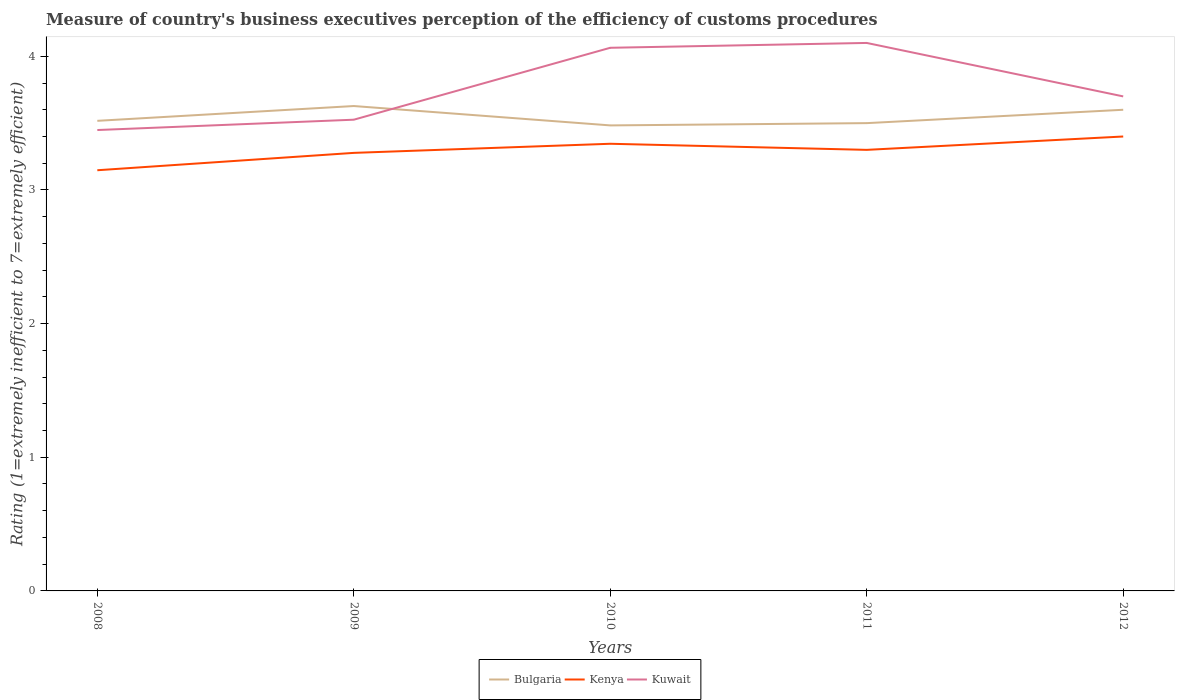How many different coloured lines are there?
Your answer should be compact. 3. Is the number of lines equal to the number of legend labels?
Give a very brief answer. Yes. Across all years, what is the maximum rating of the efficiency of customs procedure in Bulgaria?
Make the answer very short. 3.48. In which year was the rating of the efficiency of customs procedure in Bulgaria maximum?
Offer a terse response. 2010. What is the total rating of the efficiency of customs procedure in Kuwait in the graph?
Make the answer very short. -0.62. What is the difference between the highest and the second highest rating of the efficiency of customs procedure in Kuwait?
Your answer should be very brief. 0.65. How many years are there in the graph?
Your response must be concise. 5. What is the difference between two consecutive major ticks on the Y-axis?
Provide a succinct answer. 1. Does the graph contain any zero values?
Give a very brief answer. No. Does the graph contain grids?
Your answer should be very brief. No. How many legend labels are there?
Ensure brevity in your answer.  3. What is the title of the graph?
Keep it short and to the point. Measure of country's business executives perception of the efficiency of customs procedures. Does "Bhutan" appear as one of the legend labels in the graph?
Your answer should be compact. No. What is the label or title of the X-axis?
Your answer should be very brief. Years. What is the label or title of the Y-axis?
Your answer should be very brief. Rating (1=extremely inefficient to 7=extremely efficient). What is the Rating (1=extremely inefficient to 7=extremely efficient) in Bulgaria in 2008?
Provide a succinct answer. 3.52. What is the Rating (1=extremely inefficient to 7=extremely efficient) in Kenya in 2008?
Your response must be concise. 3.15. What is the Rating (1=extremely inefficient to 7=extremely efficient) in Kuwait in 2008?
Your answer should be very brief. 3.45. What is the Rating (1=extremely inefficient to 7=extremely efficient) in Bulgaria in 2009?
Your answer should be compact. 3.63. What is the Rating (1=extremely inefficient to 7=extremely efficient) of Kenya in 2009?
Make the answer very short. 3.28. What is the Rating (1=extremely inefficient to 7=extremely efficient) of Kuwait in 2009?
Provide a succinct answer. 3.53. What is the Rating (1=extremely inefficient to 7=extremely efficient) of Bulgaria in 2010?
Offer a terse response. 3.48. What is the Rating (1=extremely inefficient to 7=extremely efficient) in Kenya in 2010?
Offer a very short reply. 3.35. What is the Rating (1=extremely inefficient to 7=extremely efficient) of Kuwait in 2010?
Make the answer very short. 4.06. What is the Rating (1=extremely inefficient to 7=extremely efficient) in Bulgaria in 2012?
Offer a terse response. 3.6. Across all years, what is the maximum Rating (1=extremely inefficient to 7=extremely efficient) in Bulgaria?
Your answer should be compact. 3.63. Across all years, what is the maximum Rating (1=extremely inefficient to 7=extremely efficient) of Kenya?
Ensure brevity in your answer.  3.4. Across all years, what is the maximum Rating (1=extremely inefficient to 7=extremely efficient) in Kuwait?
Offer a terse response. 4.1. Across all years, what is the minimum Rating (1=extremely inefficient to 7=extremely efficient) of Bulgaria?
Offer a very short reply. 3.48. Across all years, what is the minimum Rating (1=extremely inefficient to 7=extremely efficient) of Kenya?
Your response must be concise. 3.15. Across all years, what is the minimum Rating (1=extremely inefficient to 7=extremely efficient) in Kuwait?
Provide a succinct answer. 3.45. What is the total Rating (1=extremely inefficient to 7=extremely efficient) of Bulgaria in the graph?
Offer a terse response. 17.73. What is the total Rating (1=extremely inefficient to 7=extremely efficient) of Kenya in the graph?
Give a very brief answer. 16.47. What is the total Rating (1=extremely inefficient to 7=extremely efficient) in Kuwait in the graph?
Provide a short and direct response. 18.84. What is the difference between the Rating (1=extremely inefficient to 7=extremely efficient) in Bulgaria in 2008 and that in 2009?
Your answer should be compact. -0.11. What is the difference between the Rating (1=extremely inefficient to 7=extremely efficient) in Kenya in 2008 and that in 2009?
Offer a very short reply. -0.13. What is the difference between the Rating (1=extremely inefficient to 7=extremely efficient) of Kuwait in 2008 and that in 2009?
Offer a very short reply. -0.08. What is the difference between the Rating (1=extremely inefficient to 7=extremely efficient) of Bulgaria in 2008 and that in 2010?
Your response must be concise. 0.03. What is the difference between the Rating (1=extremely inefficient to 7=extremely efficient) of Kenya in 2008 and that in 2010?
Keep it short and to the point. -0.2. What is the difference between the Rating (1=extremely inefficient to 7=extremely efficient) of Kuwait in 2008 and that in 2010?
Offer a terse response. -0.62. What is the difference between the Rating (1=extremely inefficient to 7=extremely efficient) of Bulgaria in 2008 and that in 2011?
Ensure brevity in your answer.  0.02. What is the difference between the Rating (1=extremely inefficient to 7=extremely efficient) in Kenya in 2008 and that in 2011?
Your answer should be compact. -0.15. What is the difference between the Rating (1=extremely inefficient to 7=extremely efficient) of Kuwait in 2008 and that in 2011?
Make the answer very short. -0.65. What is the difference between the Rating (1=extremely inefficient to 7=extremely efficient) of Bulgaria in 2008 and that in 2012?
Your answer should be compact. -0.08. What is the difference between the Rating (1=extremely inefficient to 7=extremely efficient) of Kenya in 2008 and that in 2012?
Make the answer very short. -0.25. What is the difference between the Rating (1=extremely inefficient to 7=extremely efficient) of Kuwait in 2008 and that in 2012?
Give a very brief answer. -0.25. What is the difference between the Rating (1=extremely inefficient to 7=extremely efficient) in Bulgaria in 2009 and that in 2010?
Give a very brief answer. 0.14. What is the difference between the Rating (1=extremely inefficient to 7=extremely efficient) of Kenya in 2009 and that in 2010?
Make the answer very short. -0.07. What is the difference between the Rating (1=extremely inefficient to 7=extremely efficient) in Kuwait in 2009 and that in 2010?
Make the answer very short. -0.54. What is the difference between the Rating (1=extremely inefficient to 7=extremely efficient) in Bulgaria in 2009 and that in 2011?
Offer a very short reply. 0.13. What is the difference between the Rating (1=extremely inefficient to 7=extremely efficient) in Kenya in 2009 and that in 2011?
Your response must be concise. -0.02. What is the difference between the Rating (1=extremely inefficient to 7=extremely efficient) in Kuwait in 2009 and that in 2011?
Provide a succinct answer. -0.57. What is the difference between the Rating (1=extremely inefficient to 7=extremely efficient) in Bulgaria in 2009 and that in 2012?
Provide a short and direct response. 0.03. What is the difference between the Rating (1=extremely inefficient to 7=extremely efficient) of Kenya in 2009 and that in 2012?
Keep it short and to the point. -0.12. What is the difference between the Rating (1=extremely inefficient to 7=extremely efficient) of Kuwait in 2009 and that in 2012?
Give a very brief answer. -0.17. What is the difference between the Rating (1=extremely inefficient to 7=extremely efficient) of Bulgaria in 2010 and that in 2011?
Your answer should be compact. -0.02. What is the difference between the Rating (1=extremely inefficient to 7=extremely efficient) in Kenya in 2010 and that in 2011?
Make the answer very short. 0.05. What is the difference between the Rating (1=extremely inefficient to 7=extremely efficient) of Kuwait in 2010 and that in 2011?
Provide a succinct answer. -0.04. What is the difference between the Rating (1=extremely inefficient to 7=extremely efficient) of Bulgaria in 2010 and that in 2012?
Your response must be concise. -0.12. What is the difference between the Rating (1=extremely inefficient to 7=extremely efficient) of Kenya in 2010 and that in 2012?
Provide a succinct answer. -0.05. What is the difference between the Rating (1=extremely inefficient to 7=extremely efficient) of Kuwait in 2010 and that in 2012?
Ensure brevity in your answer.  0.36. What is the difference between the Rating (1=extremely inefficient to 7=extremely efficient) in Kenya in 2011 and that in 2012?
Your answer should be very brief. -0.1. What is the difference between the Rating (1=extremely inefficient to 7=extremely efficient) of Kuwait in 2011 and that in 2012?
Provide a succinct answer. 0.4. What is the difference between the Rating (1=extremely inefficient to 7=extremely efficient) of Bulgaria in 2008 and the Rating (1=extremely inefficient to 7=extremely efficient) of Kenya in 2009?
Your answer should be compact. 0.24. What is the difference between the Rating (1=extremely inefficient to 7=extremely efficient) of Bulgaria in 2008 and the Rating (1=extremely inefficient to 7=extremely efficient) of Kuwait in 2009?
Your answer should be compact. -0.01. What is the difference between the Rating (1=extremely inefficient to 7=extremely efficient) in Kenya in 2008 and the Rating (1=extremely inefficient to 7=extremely efficient) in Kuwait in 2009?
Offer a terse response. -0.38. What is the difference between the Rating (1=extremely inefficient to 7=extremely efficient) in Bulgaria in 2008 and the Rating (1=extremely inefficient to 7=extremely efficient) in Kenya in 2010?
Your answer should be compact. 0.17. What is the difference between the Rating (1=extremely inefficient to 7=extremely efficient) in Bulgaria in 2008 and the Rating (1=extremely inefficient to 7=extremely efficient) in Kuwait in 2010?
Provide a short and direct response. -0.55. What is the difference between the Rating (1=extremely inefficient to 7=extremely efficient) of Kenya in 2008 and the Rating (1=extremely inefficient to 7=extremely efficient) of Kuwait in 2010?
Your response must be concise. -0.92. What is the difference between the Rating (1=extremely inefficient to 7=extremely efficient) of Bulgaria in 2008 and the Rating (1=extremely inefficient to 7=extremely efficient) of Kenya in 2011?
Provide a succinct answer. 0.22. What is the difference between the Rating (1=extremely inefficient to 7=extremely efficient) of Bulgaria in 2008 and the Rating (1=extremely inefficient to 7=extremely efficient) of Kuwait in 2011?
Give a very brief answer. -0.58. What is the difference between the Rating (1=extremely inefficient to 7=extremely efficient) of Kenya in 2008 and the Rating (1=extremely inefficient to 7=extremely efficient) of Kuwait in 2011?
Your answer should be very brief. -0.95. What is the difference between the Rating (1=extremely inefficient to 7=extremely efficient) of Bulgaria in 2008 and the Rating (1=extremely inefficient to 7=extremely efficient) of Kenya in 2012?
Your answer should be compact. 0.12. What is the difference between the Rating (1=extremely inefficient to 7=extremely efficient) in Bulgaria in 2008 and the Rating (1=extremely inefficient to 7=extremely efficient) in Kuwait in 2012?
Make the answer very short. -0.18. What is the difference between the Rating (1=extremely inefficient to 7=extremely efficient) in Kenya in 2008 and the Rating (1=extremely inefficient to 7=extremely efficient) in Kuwait in 2012?
Offer a terse response. -0.55. What is the difference between the Rating (1=extremely inefficient to 7=extremely efficient) of Bulgaria in 2009 and the Rating (1=extremely inefficient to 7=extremely efficient) of Kenya in 2010?
Give a very brief answer. 0.28. What is the difference between the Rating (1=extremely inefficient to 7=extremely efficient) in Bulgaria in 2009 and the Rating (1=extremely inefficient to 7=extremely efficient) in Kuwait in 2010?
Give a very brief answer. -0.44. What is the difference between the Rating (1=extremely inefficient to 7=extremely efficient) of Kenya in 2009 and the Rating (1=extremely inefficient to 7=extremely efficient) of Kuwait in 2010?
Your answer should be compact. -0.79. What is the difference between the Rating (1=extremely inefficient to 7=extremely efficient) of Bulgaria in 2009 and the Rating (1=extremely inefficient to 7=extremely efficient) of Kenya in 2011?
Make the answer very short. 0.33. What is the difference between the Rating (1=extremely inefficient to 7=extremely efficient) of Bulgaria in 2009 and the Rating (1=extremely inefficient to 7=extremely efficient) of Kuwait in 2011?
Your response must be concise. -0.47. What is the difference between the Rating (1=extremely inefficient to 7=extremely efficient) of Kenya in 2009 and the Rating (1=extremely inefficient to 7=extremely efficient) of Kuwait in 2011?
Keep it short and to the point. -0.82. What is the difference between the Rating (1=extremely inefficient to 7=extremely efficient) in Bulgaria in 2009 and the Rating (1=extremely inefficient to 7=extremely efficient) in Kenya in 2012?
Your response must be concise. 0.23. What is the difference between the Rating (1=extremely inefficient to 7=extremely efficient) of Bulgaria in 2009 and the Rating (1=extremely inefficient to 7=extremely efficient) of Kuwait in 2012?
Provide a short and direct response. -0.07. What is the difference between the Rating (1=extremely inefficient to 7=extremely efficient) in Kenya in 2009 and the Rating (1=extremely inefficient to 7=extremely efficient) in Kuwait in 2012?
Your response must be concise. -0.42. What is the difference between the Rating (1=extremely inefficient to 7=extremely efficient) in Bulgaria in 2010 and the Rating (1=extremely inefficient to 7=extremely efficient) in Kenya in 2011?
Give a very brief answer. 0.18. What is the difference between the Rating (1=extremely inefficient to 7=extremely efficient) in Bulgaria in 2010 and the Rating (1=extremely inefficient to 7=extremely efficient) in Kuwait in 2011?
Your answer should be compact. -0.62. What is the difference between the Rating (1=extremely inefficient to 7=extremely efficient) of Kenya in 2010 and the Rating (1=extremely inefficient to 7=extremely efficient) of Kuwait in 2011?
Your answer should be very brief. -0.75. What is the difference between the Rating (1=extremely inefficient to 7=extremely efficient) of Bulgaria in 2010 and the Rating (1=extremely inefficient to 7=extremely efficient) of Kenya in 2012?
Offer a terse response. 0.08. What is the difference between the Rating (1=extremely inefficient to 7=extremely efficient) of Bulgaria in 2010 and the Rating (1=extremely inefficient to 7=extremely efficient) of Kuwait in 2012?
Ensure brevity in your answer.  -0.22. What is the difference between the Rating (1=extremely inefficient to 7=extremely efficient) in Kenya in 2010 and the Rating (1=extremely inefficient to 7=extremely efficient) in Kuwait in 2012?
Give a very brief answer. -0.35. What is the difference between the Rating (1=extremely inefficient to 7=extremely efficient) of Bulgaria in 2011 and the Rating (1=extremely inefficient to 7=extremely efficient) of Kenya in 2012?
Offer a very short reply. 0.1. What is the difference between the Rating (1=extremely inefficient to 7=extremely efficient) in Bulgaria in 2011 and the Rating (1=extremely inefficient to 7=extremely efficient) in Kuwait in 2012?
Offer a very short reply. -0.2. What is the average Rating (1=extremely inefficient to 7=extremely efficient) of Bulgaria per year?
Your answer should be compact. 3.55. What is the average Rating (1=extremely inefficient to 7=extremely efficient) of Kenya per year?
Your answer should be compact. 3.29. What is the average Rating (1=extremely inefficient to 7=extremely efficient) of Kuwait per year?
Provide a short and direct response. 3.77. In the year 2008, what is the difference between the Rating (1=extremely inefficient to 7=extremely efficient) in Bulgaria and Rating (1=extremely inefficient to 7=extremely efficient) in Kenya?
Offer a terse response. 0.37. In the year 2008, what is the difference between the Rating (1=extremely inefficient to 7=extremely efficient) of Bulgaria and Rating (1=extremely inefficient to 7=extremely efficient) of Kuwait?
Your response must be concise. 0.07. In the year 2008, what is the difference between the Rating (1=extremely inefficient to 7=extremely efficient) in Kenya and Rating (1=extremely inefficient to 7=extremely efficient) in Kuwait?
Provide a succinct answer. -0.3. In the year 2009, what is the difference between the Rating (1=extremely inefficient to 7=extremely efficient) in Bulgaria and Rating (1=extremely inefficient to 7=extremely efficient) in Kenya?
Keep it short and to the point. 0.35. In the year 2009, what is the difference between the Rating (1=extremely inefficient to 7=extremely efficient) of Bulgaria and Rating (1=extremely inefficient to 7=extremely efficient) of Kuwait?
Your response must be concise. 0.1. In the year 2009, what is the difference between the Rating (1=extremely inefficient to 7=extremely efficient) in Kenya and Rating (1=extremely inefficient to 7=extremely efficient) in Kuwait?
Give a very brief answer. -0.25. In the year 2010, what is the difference between the Rating (1=extremely inefficient to 7=extremely efficient) in Bulgaria and Rating (1=extremely inefficient to 7=extremely efficient) in Kenya?
Your response must be concise. 0.14. In the year 2010, what is the difference between the Rating (1=extremely inefficient to 7=extremely efficient) of Bulgaria and Rating (1=extremely inefficient to 7=extremely efficient) of Kuwait?
Provide a succinct answer. -0.58. In the year 2010, what is the difference between the Rating (1=extremely inefficient to 7=extremely efficient) of Kenya and Rating (1=extremely inefficient to 7=extremely efficient) of Kuwait?
Ensure brevity in your answer.  -0.72. In the year 2011, what is the difference between the Rating (1=extremely inefficient to 7=extremely efficient) of Bulgaria and Rating (1=extremely inefficient to 7=extremely efficient) of Kenya?
Make the answer very short. 0.2. In the year 2012, what is the difference between the Rating (1=extremely inefficient to 7=extremely efficient) in Bulgaria and Rating (1=extremely inefficient to 7=extremely efficient) in Kenya?
Make the answer very short. 0.2. In the year 2012, what is the difference between the Rating (1=extremely inefficient to 7=extremely efficient) of Kenya and Rating (1=extremely inefficient to 7=extremely efficient) of Kuwait?
Ensure brevity in your answer.  -0.3. What is the ratio of the Rating (1=extremely inefficient to 7=extremely efficient) in Bulgaria in 2008 to that in 2009?
Give a very brief answer. 0.97. What is the ratio of the Rating (1=extremely inefficient to 7=extremely efficient) in Kenya in 2008 to that in 2009?
Keep it short and to the point. 0.96. What is the ratio of the Rating (1=extremely inefficient to 7=extremely efficient) in Kuwait in 2008 to that in 2009?
Keep it short and to the point. 0.98. What is the ratio of the Rating (1=extremely inefficient to 7=extremely efficient) in Bulgaria in 2008 to that in 2010?
Provide a succinct answer. 1.01. What is the ratio of the Rating (1=extremely inefficient to 7=extremely efficient) in Kenya in 2008 to that in 2010?
Provide a succinct answer. 0.94. What is the ratio of the Rating (1=extremely inefficient to 7=extremely efficient) of Kuwait in 2008 to that in 2010?
Ensure brevity in your answer.  0.85. What is the ratio of the Rating (1=extremely inefficient to 7=extremely efficient) of Kenya in 2008 to that in 2011?
Make the answer very short. 0.95. What is the ratio of the Rating (1=extremely inefficient to 7=extremely efficient) of Kuwait in 2008 to that in 2011?
Offer a terse response. 0.84. What is the ratio of the Rating (1=extremely inefficient to 7=extremely efficient) of Bulgaria in 2008 to that in 2012?
Keep it short and to the point. 0.98. What is the ratio of the Rating (1=extremely inefficient to 7=extremely efficient) of Kenya in 2008 to that in 2012?
Provide a succinct answer. 0.93. What is the ratio of the Rating (1=extremely inefficient to 7=extremely efficient) of Kuwait in 2008 to that in 2012?
Provide a short and direct response. 0.93. What is the ratio of the Rating (1=extremely inefficient to 7=extremely efficient) in Bulgaria in 2009 to that in 2010?
Give a very brief answer. 1.04. What is the ratio of the Rating (1=extremely inefficient to 7=extremely efficient) of Kenya in 2009 to that in 2010?
Your answer should be compact. 0.98. What is the ratio of the Rating (1=extremely inefficient to 7=extremely efficient) of Kuwait in 2009 to that in 2010?
Your answer should be compact. 0.87. What is the ratio of the Rating (1=extremely inefficient to 7=extremely efficient) of Bulgaria in 2009 to that in 2011?
Give a very brief answer. 1.04. What is the ratio of the Rating (1=extremely inefficient to 7=extremely efficient) in Kuwait in 2009 to that in 2011?
Give a very brief answer. 0.86. What is the ratio of the Rating (1=extremely inefficient to 7=extremely efficient) of Kenya in 2009 to that in 2012?
Keep it short and to the point. 0.96. What is the ratio of the Rating (1=extremely inefficient to 7=extremely efficient) in Kuwait in 2009 to that in 2012?
Keep it short and to the point. 0.95. What is the ratio of the Rating (1=extremely inefficient to 7=extremely efficient) of Bulgaria in 2010 to that in 2011?
Provide a short and direct response. 1. What is the ratio of the Rating (1=extremely inefficient to 7=extremely efficient) in Kenya in 2010 to that in 2011?
Your answer should be compact. 1.01. What is the ratio of the Rating (1=extremely inefficient to 7=extremely efficient) of Kuwait in 2010 to that in 2011?
Your answer should be very brief. 0.99. What is the ratio of the Rating (1=extremely inefficient to 7=extremely efficient) in Bulgaria in 2010 to that in 2012?
Offer a terse response. 0.97. What is the ratio of the Rating (1=extremely inefficient to 7=extremely efficient) in Kuwait in 2010 to that in 2012?
Your response must be concise. 1.1. What is the ratio of the Rating (1=extremely inefficient to 7=extremely efficient) in Bulgaria in 2011 to that in 2012?
Offer a very short reply. 0.97. What is the ratio of the Rating (1=extremely inefficient to 7=extremely efficient) of Kenya in 2011 to that in 2012?
Make the answer very short. 0.97. What is the ratio of the Rating (1=extremely inefficient to 7=extremely efficient) of Kuwait in 2011 to that in 2012?
Provide a succinct answer. 1.11. What is the difference between the highest and the second highest Rating (1=extremely inefficient to 7=extremely efficient) of Bulgaria?
Your answer should be compact. 0.03. What is the difference between the highest and the second highest Rating (1=extremely inefficient to 7=extremely efficient) of Kenya?
Ensure brevity in your answer.  0.05. What is the difference between the highest and the second highest Rating (1=extremely inefficient to 7=extremely efficient) in Kuwait?
Give a very brief answer. 0.04. What is the difference between the highest and the lowest Rating (1=extremely inefficient to 7=extremely efficient) of Bulgaria?
Make the answer very short. 0.14. What is the difference between the highest and the lowest Rating (1=extremely inefficient to 7=extremely efficient) of Kenya?
Your response must be concise. 0.25. What is the difference between the highest and the lowest Rating (1=extremely inefficient to 7=extremely efficient) of Kuwait?
Keep it short and to the point. 0.65. 